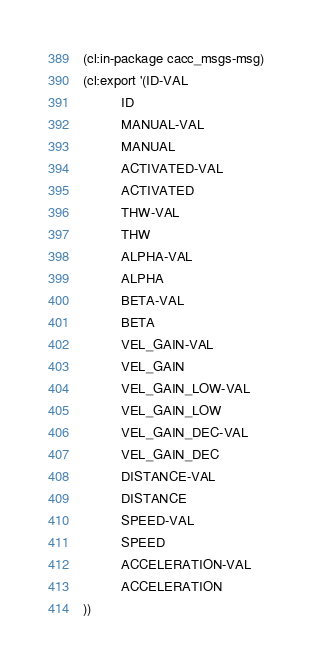<code> <loc_0><loc_0><loc_500><loc_500><_Lisp_>(cl:in-package cacc_msgs-msg)
(cl:export '(ID-VAL
          ID
          MANUAL-VAL
          MANUAL
          ACTIVATED-VAL
          ACTIVATED
          THW-VAL
          THW
          ALPHA-VAL
          ALPHA
          BETA-VAL
          BETA
          VEL_GAIN-VAL
          VEL_GAIN
          VEL_GAIN_LOW-VAL
          VEL_GAIN_LOW
          VEL_GAIN_DEC-VAL
          VEL_GAIN_DEC
          DISTANCE-VAL
          DISTANCE
          SPEED-VAL
          SPEED
          ACCELERATION-VAL
          ACCELERATION
))</code> 